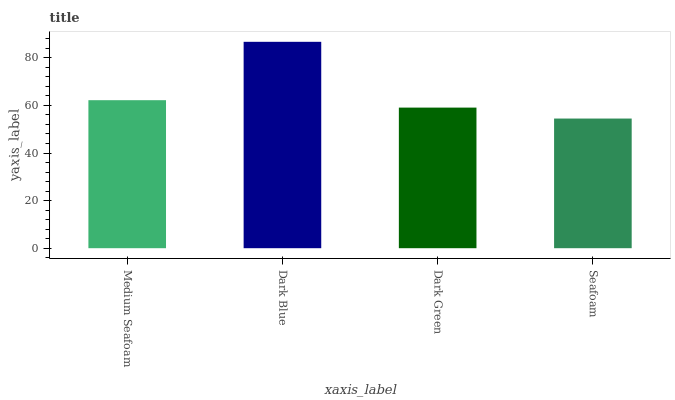Is Seafoam the minimum?
Answer yes or no. Yes. Is Dark Blue the maximum?
Answer yes or no. Yes. Is Dark Green the minimum?
Answer yes or no. No. Is Dark Green the maximum?
Answer yes or no. No. Is Dark Blue greater than Dark Green?
Answer yes or no. Yes. Is Dark Green less than Dark Blue?
Answer yes or no. Yes. Is Dark Green greater than Dark Blue?
Answer yes or no. No. Is Dark Blue less than Dark Green?
Answer yes or no. No. Is Medium Seafoam the high median?
Answer yes or no. Yes. Is Dark Green the low median?
Answer yes or no. Yes. Is Dark Blue the high median?
Answer yes or no. No. Is Dark Blue the low median?
Answer yes or no. No. 